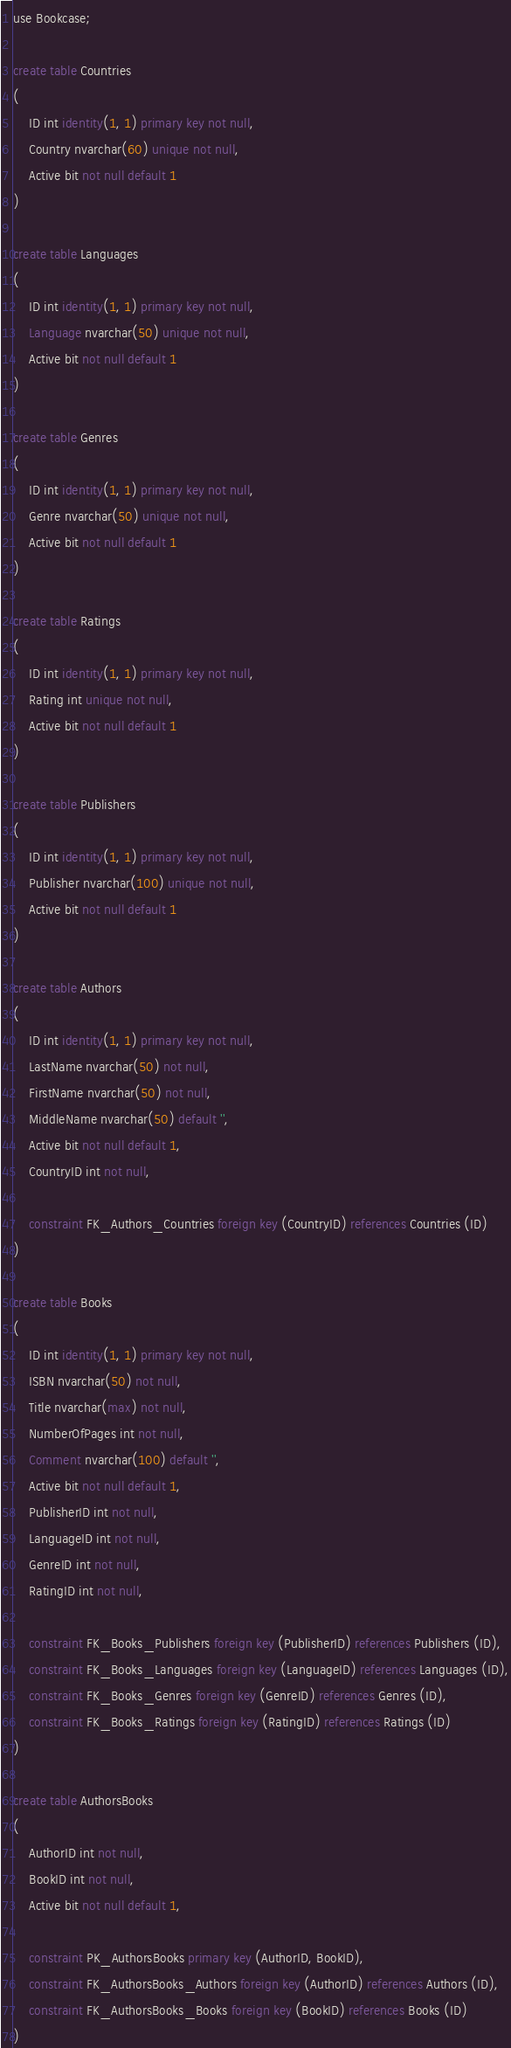Convert code to text. <code><loc_0><loc_0><loc_500><loc_500><_SQL_>use Bookcase;

create table Countries
(
    ID int identity(1, 1) primary key not null,
    Country nvarchar(60) unique not null,
    Active bit not null default 1
)

create table Languages
(
    ID int identity(1, 1) primary key not null,
    Language nvarchar(50) unique not null,
    Active bit not null default 1
)

create table Genres
(
    ID int identity(1, 1) primary key not null,
    Genre nvarchar(50) unique not null,
    Active bit not null default 1
)

create table Ratings
(
    ID int identity(1, 1) primary key not null,
    Rating int unique not null,
    Active bit not null default 1
)

create table Publishers
(
    ID int identity(1, 1) primary key not null,
    Publisher nvarchar(100) unique not null,
    Active bit not null default 1
)

create table Authors
(
    ID int identity(1, 1) primary key not null,
    LastName nvarchar(50) not null,
    FirstName nvarchar(50) not null,
    MiddleName nvarchar(50) default '',
    Active bit not null default 1,
    CountryID int not null,

    constraint FK_Authors_Countries foreign key (CountryID) references Countries (ID)
)

create table Books
(
    ID int identity(1, 1) primary key not null,
    ISBN nvarchar(50) not null,
    Title nvarchar(max) not null,
    NumberOfPages int not null,
    Comment nvarchar(100) default '',
    Active bit not null default 1,
    PublisherID int not null,
    LanguageID int not null,
    GenreID int not null,
    RatingID int not null,

    constraint FK_Books_Publishers foreign key (PublisherID) references Publishers (ID),
    constraint FK_Books_Languages foreign key (LanguageID) references Languages (ID),
    constraint FK_Books_Genres foreign key (GenreID) references Genres (ID),
    constraint FK_Books_Ratings foreign key (RatingID) references Ratings (ID)
)

create table AuthorsBooks
(
    AuthorID int not null,
    BookID int not null,
    Active bit not null default 1,

    constraint PK_AuthorsBooks primary key (AuthorID, BookID),
    constraint FK_AuthorsBooks_Authors foreign key (AuthorID) references Authors (ID),
    constraint FK_AuthorsBooks_Books foreign key (BookID) references Books (ID)
)
</code> 